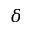<formula> <loc_0><loc_0><loc_500><loc_500>\delta</formula> 